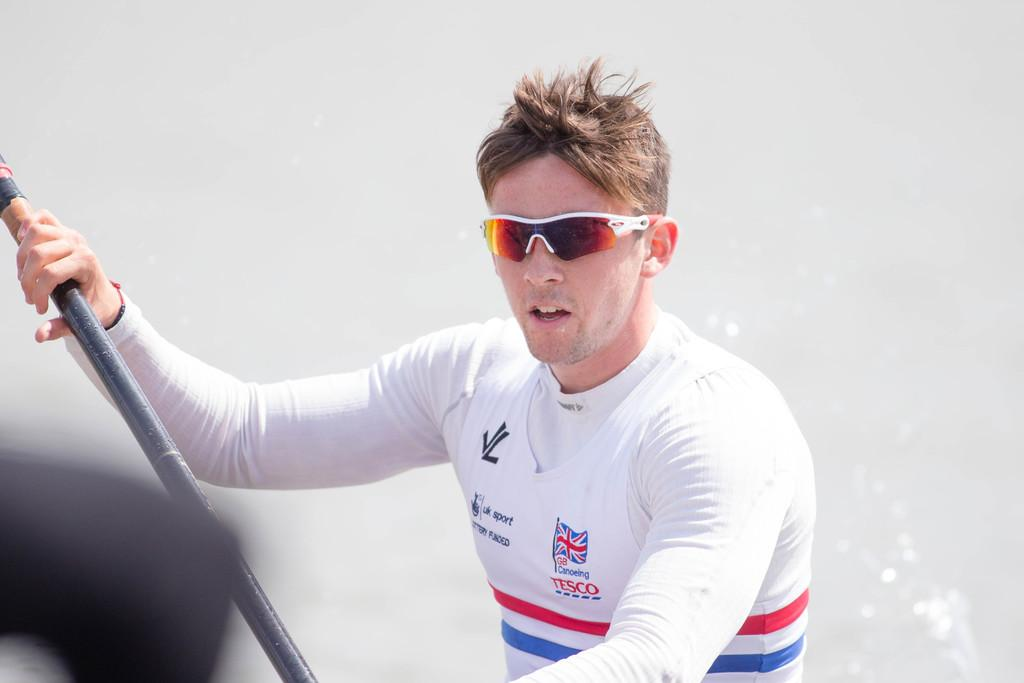What can be seen in the image? There is a person in the image. What is the person wearing? The person is wearing goggles. What is the person holding in his hand? The person is holding a stick in his hand. What is the color of the background in the image? The background of the image is white. What type of pest can be seen crawling on the person's goggles in the image? There is no pest visible on the person's goggles in the image. What is the person watching in the image? The image does not show the person watching anything, as there is no reference to a screen or any activity that would involve watching. 